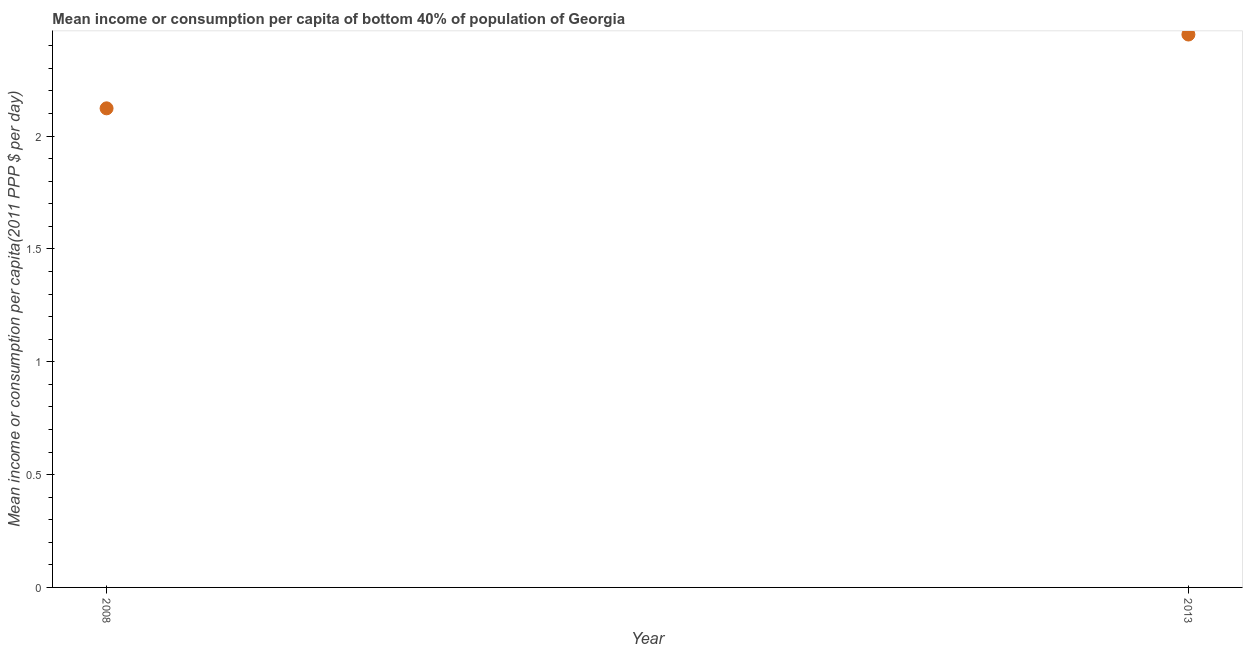What is the mean income or consumption in 2008?
Make the answer very short. 2.12. Across all years, what is the maximum mean income or consumption?
Give a very brief answer. 2.45. Across all years, what is the minimum mean income or consumption?
Your response must be concise. 2.12. In which year was the mean income or consumption maximum?
Provide a succinct answer. 2013. In which year was the mean income or consumption minimum?
Keep it short and to the point. 2008. What is the sum of the mean income or consumption?
Your answer should be compact. 4.57. What is the difference between the mean income or consumption in 2008 and 2013?
Keep it short and to the point. -0.33. What is the average mean income or consumption per year?
Your response must be concise. 2.29. What is the median mean income or consumption?
Your response must be concise. 2.29. In how many years, is the mean income or consumption greater than 1 $?
Ensure brevity in your answer.  2. Do a majority of the years between 2013 and 2008 (inclusive) have mean income or consumption greater than 1.9 $?
Offer a very short reply. No. What is the ratio of the mean income or consumption in 2008 to that in 2013?
Give a very brief answer. 0.87. In how many years, is the mean income or consumption greater than the average mean income or consumption taken over all years?
Your answer should be compact. 1. Does the mean income or consumption monotonically increase over the years?
Ensure brevity in your answer.  Yes. How many years are there in the graph?
Ensure brevity in your answer.  2. What is the difference between two consecutive major ticks on the Y-axis?
Make the answer very short. 0.5. Are the values on the major ticks of Y-axis written in scientific E-notation?
Provide a short and direct response. No. Does the graph contain grids?
Your answer should be very brief. No. What is the title of the graph?
Ensure brevity in your answer.  Mean income or consumption per capita of bottom 40% of population of Georgia. What is the label or title of the X-axis?
Offer a terse response. Year. What is the label or title of the Y-axis?
Provide a succinct answer. Mean income or consumption per capita(2011 PPP $ per day). What is the Mean income or consumption per capita(2011 PPP $ per day) in 2008?
Your answer should be compact. 2.12. What is the Mean income or consumption per capita(2011 PPP $ per day) in 2013?
Provide a succinct answer. 2.45. What is the difference between the Mean income or consumption per capita(2011 PPP $ per day) in 2008 and 2013?
Ensure brevity in your answer.  -0.33. What is the ratio of the Mean income or consumption per capita(2011 PPP $ per day) in 2008 to that in 2013?
Give a very brief answer. 0.87. 